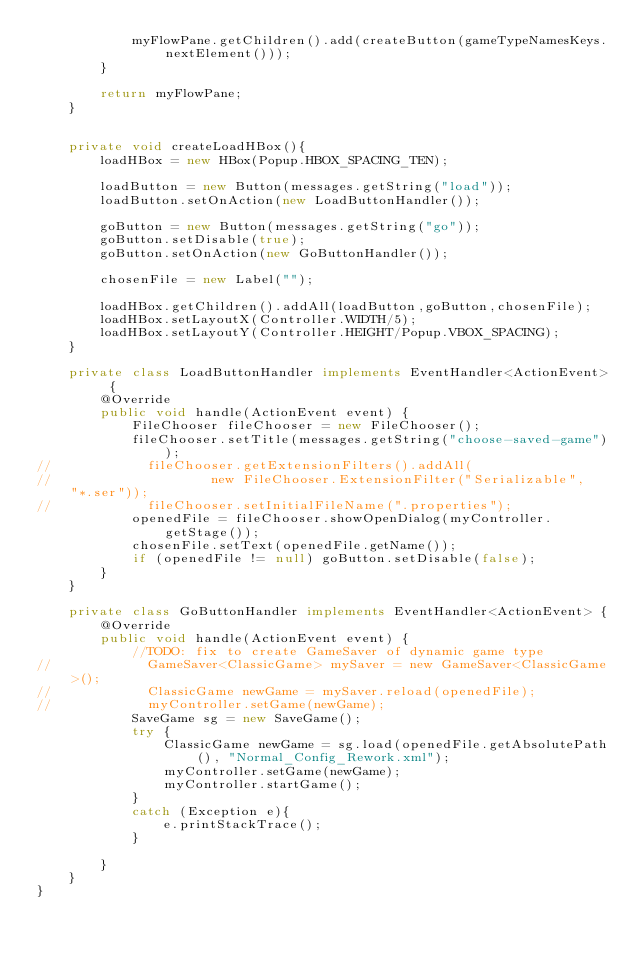Convert code to text. <code><loc_0><loc_0><loc_500><loc_500><_Java_>            myFlowPane.getChildren().add(createButton(gameTypeNamesKeys.nextElement()));
        }

        return myFlowPane;
    }


    private void createLoadHBox(){
        loadHBox = new HBox(Popup.HBOX_SPACING_TEN);

        loadButton = new Button(messages.getString("load"));
        loadButton.setOnAction(new LoadButtonHandler());

        goButton = new Button(messages.getString("go"));
        goButton.setDisable(true);
        goButton.setOnAction(new GoButtonHandler());

        chosenFile = new Label("");

        loadHBox.getChildren().addAll(loadButton,goButton,chosenFile);
        loadHBox.setLayoutX(Controller.WIDTH/5);
        loadHBox.setLayoutY(Controller.HEIGHT/Popup.VBOX_SPACING);
    }

    private class LoadButtonHandler implements EventHandler<ActionEvent> {
        @Override
        public void handle(ActionEvent event) {
            FileChooser fileChooser = new FileChooser();
            fileChooser.setTitle(messages.getString("choose-saved-game"));
//            fileChooser.getExtensionFilters().addAll(
//                    new FileChooser.ExtensionFilter("Serializable", "*.ser"));
//            fileChooser.setInitialFileName(".properties");
            openedFile = fileChooser.showOpenDialog(myController.getStage());
            chosenFile.setText(openedFile.getName());
            if (openedFile != null) goButton.setDisable(false);
        }
    }

    private class GoButtonHandler implements EventHandler<ActionEvent> {
        @Override
        public void handle(ActionEvent event) {
            //TODO: fix to create GameSaver of dynamic game type
//            GameSaver<ClassicGame> mySaver = new GameSaver<ClassicGame>();
//            ClassicGame newGame = mySaver.reload(openedFile);
//            myController.setGame(newGame);
            SaveGame sg = new SaveGame();
            try {
                ClassicGame newGame = sg.load(openedFile.getAbsolutePath(), "Normal_Config_Rework.xml");
                myController.setGame(newGame);
                myController.startGame();
            }
            catch (Exception e){
                e.printStackTrace();
            }

        }
    }
}
</code> 